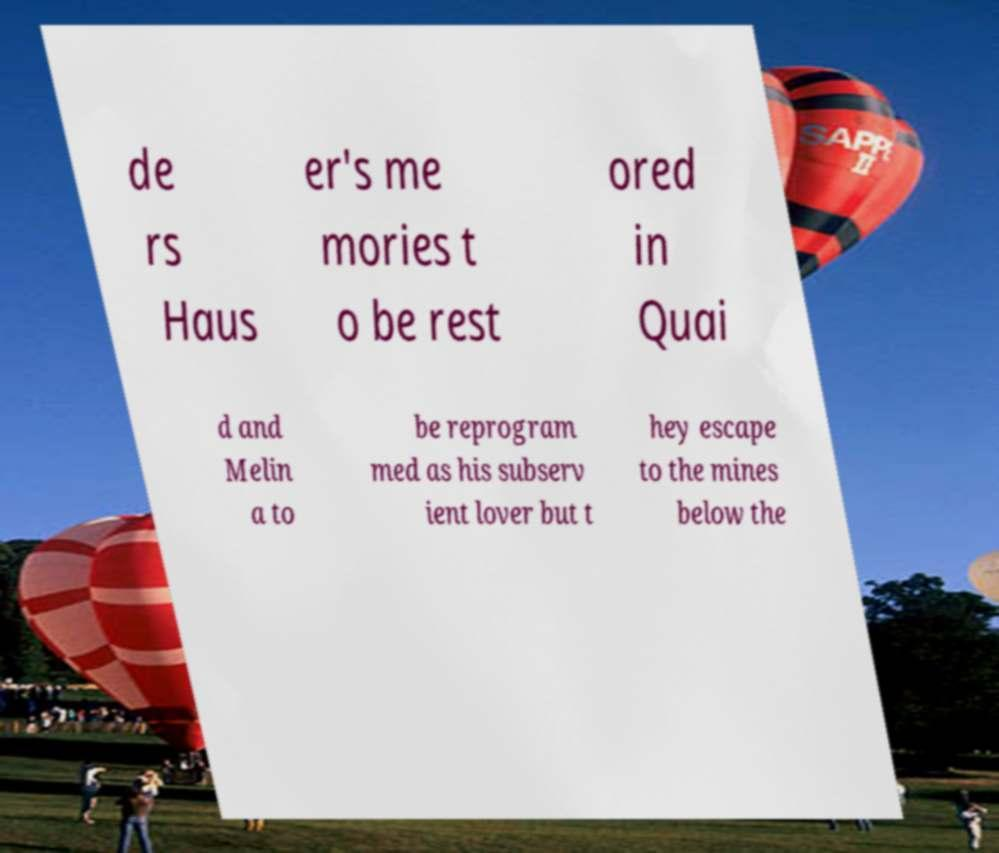I need the written content from this picture converted into text. Can you do that? de rs Haus er's me mories t o be rest ored in Quai d and Melin a to be reprogram med as his subserv ient lover but t hey escape to the mines below the 